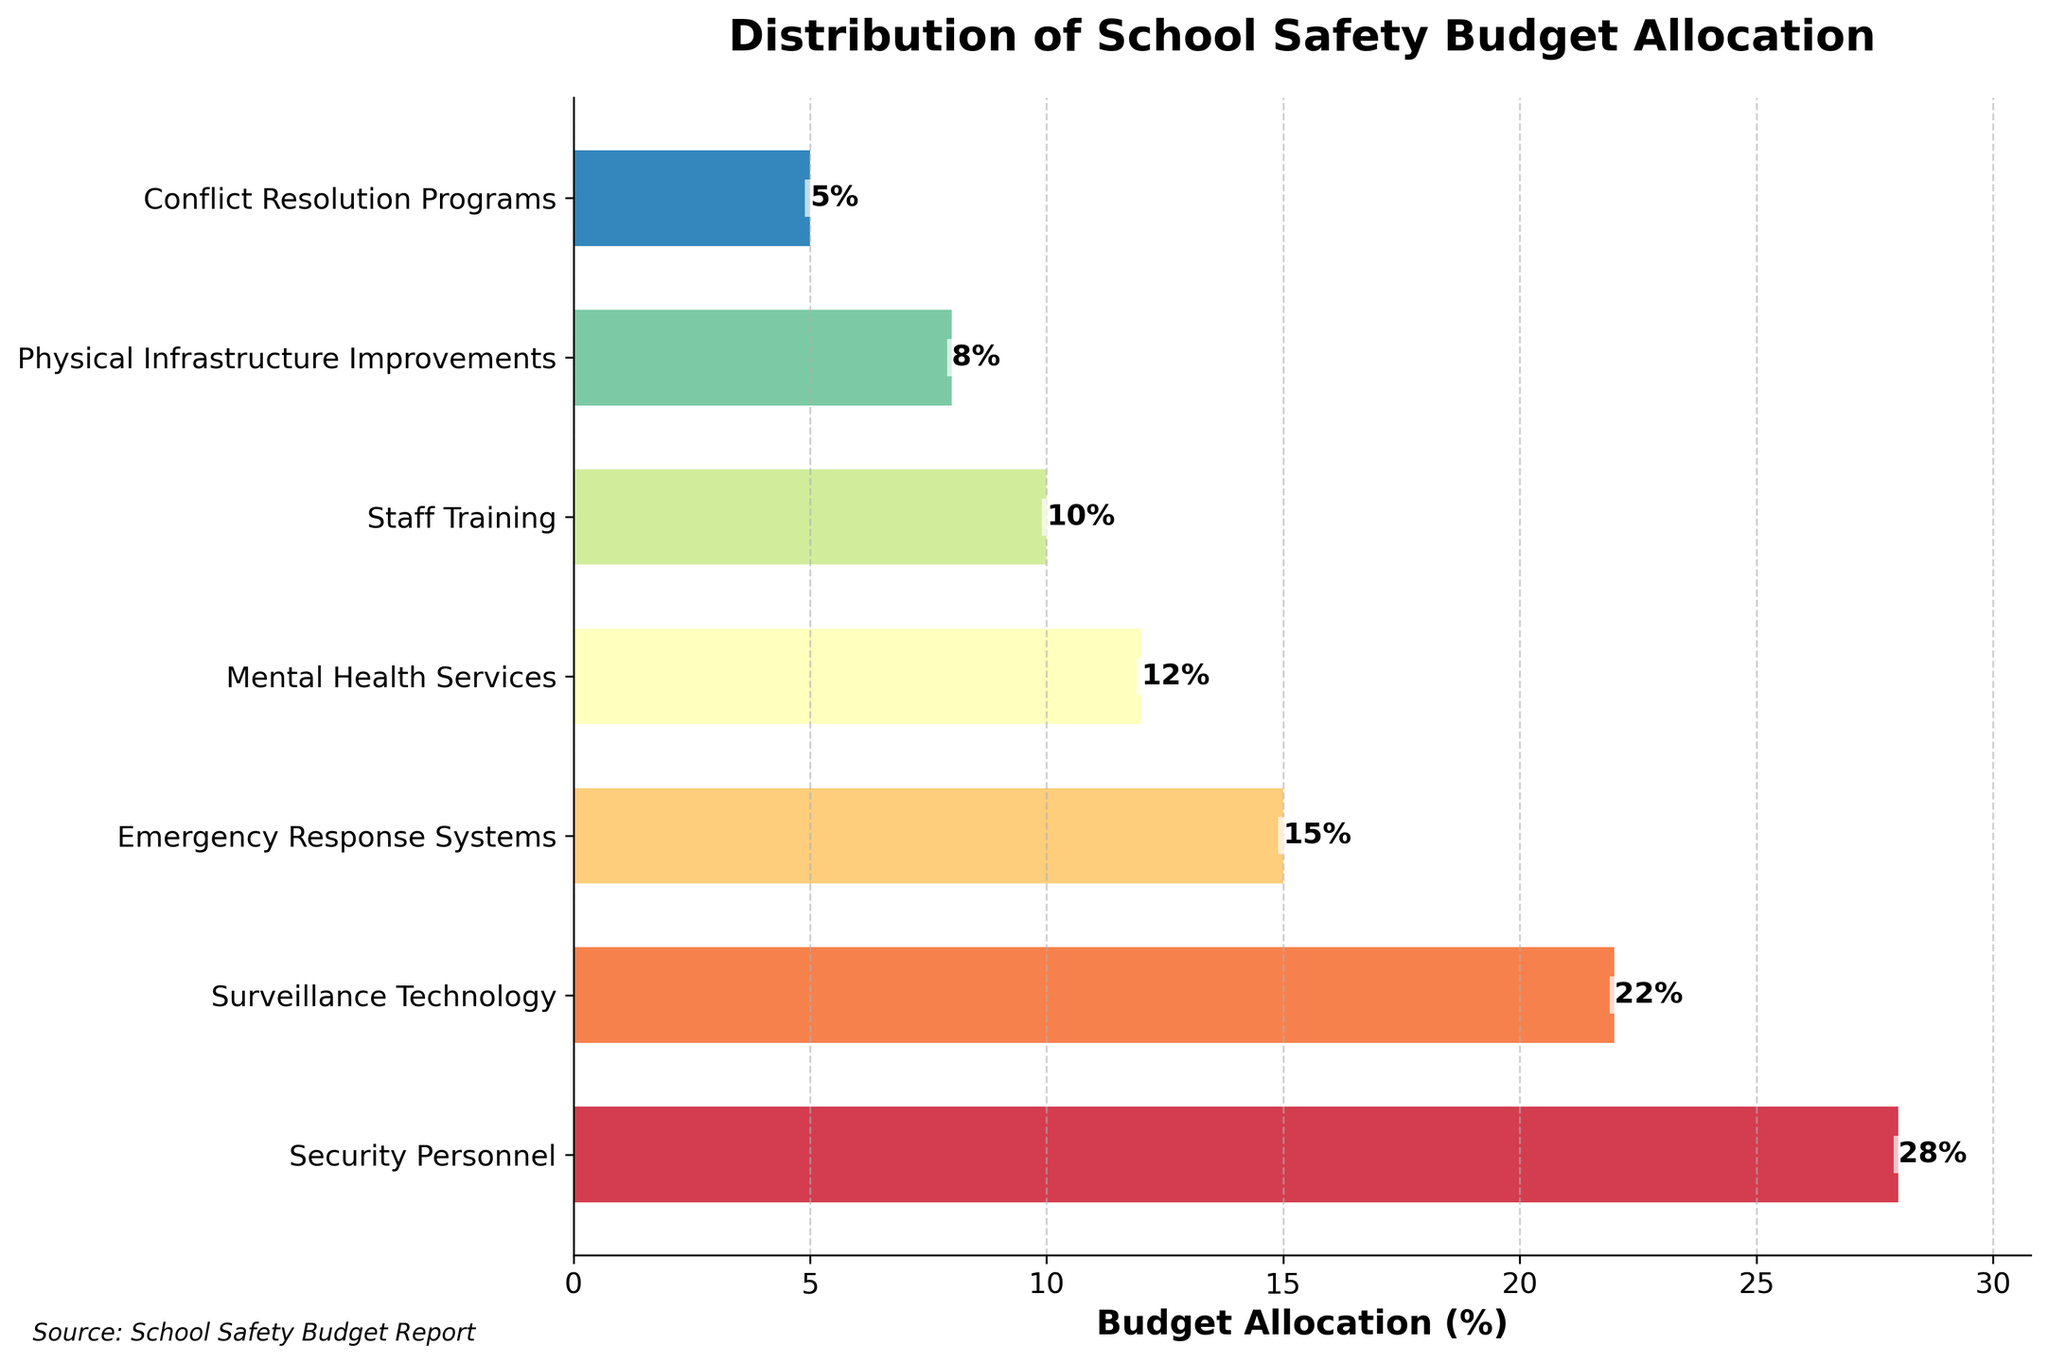What is the safety measure with the highest budget allocation? The figure shows different safety measures with their respective budget allocations. The bar corresponding to Security Personnel reaches the highest value on the x-axis with 28%.
Answer: Security Personnel How much more budget allocation do Security Personnel receive compared to Conflict Resolution Programs? The budget allocation for Security Personnel is 28%, while it is 5% for Conflict Resolution Programs. The difference is calculated as 28% - 5% = 23%.
Answer: 23% What is the total budget allocation for Surveillance Technology, Mental Health Services, and Staff Training combined? Adding up the percentages for Surveillance Technology (22%), Mental Health Services (12%), and Staff Training (10%) gives 22% + 12% + 10% = 44%.
Answer: 44% Which safety measure has allocation closest to half that of Security Personnel? Security Personnel has a 28% allocation. Half of this is 14%. Emergency Response Systems, with 15%, is the closest to this value.
Answer: Emergency Response Systems Is the budget allocation for Mental Health Services greater than that for Physical Infrastructure Improvements and Conflict Resolution Programs combined? Mental Health Services allocation is 12%. The sum of allocations for Physical Infrastructure Improvements (8%) and Conflict Resolution Programs (5%) is 8% + 5% = 13%. Since 12% < 13%, the allocation for Mental Health Services is not greater.
Answer: No Which safety measures receive less than 10% of the budget allocation? The bars for Conflict Resolution Programs and Physical Infrastructure Improvements have values less than 10% (5% and 8%, respectively).
Answer: Conflict Resolution Programs, Physical Infrastructure Improvements What is the average budget allocation across all safety measures? Sum all budget allocations and then divide by the number of measures. (28% + 22% + 15% + 12% + 10% + 8% + 5%) / 7 = 100% / 7 ≈ 14.29%.
Answer: ~14.29% What is the difference in budget allocation between Staff Training and Emergency Response Systems? The allocation for Staff Training is 10%, while it is 15% for Emergency Response Systems. The difference is 15% - 10% = 5%.
Answer: 5% Which safety measure has the shortest bar on the chart? The shortest bar corresponds to Conflict Resolution Programs with a budget allocation of 5%.
Answer: Conflict Resolution Programs 